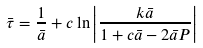<formula> <loc_0><loc_0><loc_500><loc_500>\bar { \tau } = \frac { 1 } { \bar { a } } + c \ln \left | \frac { k \bar { a } } { 1 + c \bar { a } - 2 \bar { a } P } \right |</formula> 